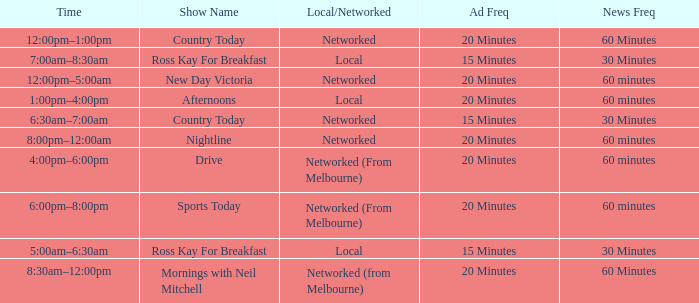Help me parse the entirety of this table. {'header': ['Time', 'Show Name', 'Local/Networked', 'Ad Freq', 'News Freq'], 'rows': [['12:00pm–1:00pm', 'Country Today', 'Networked', '20 Minutes', '60 Minutes'], ['7:00am–8:30am', 'Ross Kay For Breakfast', 'Local', '15 Minutes', '30 Minutes'], ['12:00pm–5:00am', 'New Day Victoria', 'Networked', '20 Minutes', '60 minutes'], ['1:00pm–4:00pm', 'Afternoons', 'Local', '20 Minutes', '60 minutes'], ['6:30am–7:00am', 'Country Today', 'Networked', '15 Minutes', '30 Minutes'], ['8:00pm–12:00am', 'Nightline', 'Networked', '20 Minutes', '60 minutes'], ['4:00pm–6:00pm', 'Drive', 'Networked (From Melbourne)', '20 Minutes', '60 minutes'], ['6:00pm–8:00pm', 'Sports Today', 'Networked (From Melbourne)', '20 Minutes', '60 minutes'], ['5:00am–6:30am', 'Ross Kay For Breakfast', 'Local', '15 Minutes', '30 Minutes'], ['8:30am–12:00pm', 'Mornings with Neil Mitchell', 'Networked (from Melbourne)', '20 Minutes', '60 Minutes']]} What Ad Freq has a News Freq of 60 minutes, and a Local/Networked of local? 20 Minutes. 